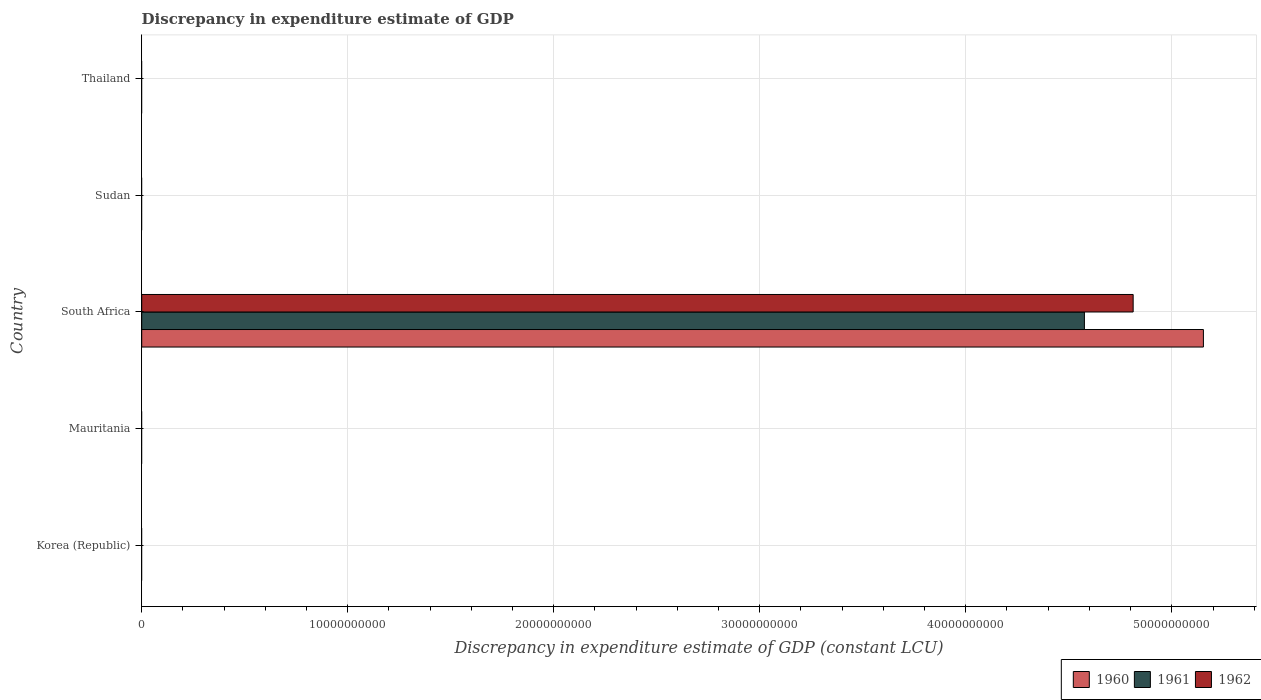Are the number of bars per tick equal to the number of legend labels?
Offer a terse response. No. How many bars are there on the 2nd tick from the top?
Provide a succinct answer. 0. What is the label of the 2nd group of bars from the top?
Keep it short and to the point. Sudan. In how many cases, is the number of bars for a given country not equal to the number of legend labels?
Make the answer very short. 4. Across all countries, what is the maximum discrepancy in expenditure estimate of GDP in 1960?
Ensure brevity in your answer.  5.15e+1. Across all countries, what is the minimum discrepancy in expenditure estimate of GDP in 1961?
Ensure brevity in your answer.  0. In which country was the discrepancy in expenditure estimate of GDP in 1960 maximum?
Make the answer very short. South Africa. What is the total discrepancy in expenditure estimate of GDP in 1960 in the graph?
Provide a short and direct response. 5.15e+1. What is the difference between the discrepancy in expenditure estimate of GDP in 1960 in South Africa and the discrepancy in expenditure estimate of GDP in 1961 in Mauritania?
Keep it short and to the point. 5.15e+1. What is the average discrepancy in expenditure estimate of GDP in 1961 per country?
Make the answer very short. 9.15e+09. What is the difference between the discrepancy in expenditure estimate of GDP in 1961 and discrepancy in expenditure estimate of GDP in 1962 in South Africa?
Provide a succinct answer. -2.37e+09. In how many countries, is the discrepancy in expenditure estimate of GDP in 1962 greater than 26000000000 LCU?
Your response must be concise. 1. What is the difference between the highest and the lowest discrepancy in expenditure estimate of GDP in 1961?
Make the answer very short. 4.58e+1. In how many countries, is the discrepancy in expenditure estimate of GDP in 1961 greater than the average discrepancy in expenditure estimate of GDP in 1961 taken over all countries?
Make the answer very short. 1. Are all the bars in the graph horizontal?
Make the answer very short. Yes. Are the values on the major ticks of X-axis written in scientific E-notation?
Your answer should be compact. No. Does the graph contain any zero values?
Your answer should be very brief. Yes. Does the graph contain grids?
Keep it short and to the point. Yes. How are the legend labels stacked?
Provide a short and direct response. Horizontal. What is the title of the graph?
Provide a short and direct response. Discrepancy in expenditure estimate of GDP. Does "1999" appear as one of the legend labels in the graph?
Ensure brevity in your answer.  No. What is the label or title of the X-axis?
Your answer should be very brief. Discrepancy in expenditure estimate of GDP (constant LCU). What is the label or title of the Y-axis?
Give a very brief answer. Country. What is the Discrepancy in expenditure estimate of GDP (constant LCU) of 1961 in Korea (Republic)?
Offer a very short reply. 0. What is the Discrepancy in expenditure estimate of GDP (constant LCU) in 1962 in Korea (Republic)?
Make the answer very short. 0. What is the Discrepancy in expenditure estimate of GDP (constant LCU) of 1960 in Mauritania?
Keep it short and to the point. 0. What is the Discrepancy in expenditure estimate of GDP (constant LCU) in 1960 in South Africa?
Make the answer very short. 5.15e+1. What is the Discrepancy in expenditure estimate of GDP (constant LCU) in 1961 in South Africa?
Make the answer very short. 4.58e+1. What is the Discrepancy in expenditure estimate of GDP (constant LCU) of 1962 in South Africa?
Make the answer very short. 4.81e+1. What is the Discrepancy in expenditure estimate of GDP (constant LCU) of 1962 in Sudan?
Your answer should be compact. 0. What is the Discrepancy in expenditure estimate of GDP (constant LCU) of 1960 in Thailand?
Keep it short and to the point. 0. What is the Discrepancy in expenditure estimate of GDP (constant LCU) of 1961 in Thailand?
Give a very brief answer. 0. Across all countries, what is the maximum Discrepancy in expenditure estimate of GDP (constant LCU) of 1960?
Make the answer very short. 5.15e+1. Across all countries, what is the maximum Discrepancy in expenditure estimate of GDP (constant LCU) of 1961?
Offer a very short reply. 4.58e+1. Across all countries, what is the maximum Discrepancy in expenditure estimate of GDP (constant LCU) in 1962?
Your answer should be compact. 4.81e+1. Across all countries, what is the minimum Discrepancy in expenditure estimate of GDP (constant LCU) of 1962?
Offer a terse response. 0. What is the total Discrepancy in expenditure estimate of GDP (constant LCU) in 1960 in the graph?
Make the answer very short. 5.15e+1. What is the total Discrepancy in expenditure estimate of GDP (constant LCU) in 1961 in the graph?
Keep it short and to the point. 4.58e+1. What is the total Discrepancy in expenditure estimate of GDP (constant LCU) of 1962 in the graph?
Your answer should be compact. 4.81e+1. What is the average Discrepancy in expenditure estimate of GDP (constant LCU) in 1960 per country?
Your response must be concise. 1.03e+1. What is the average Discrepancy in expenditure estimate of GDP (constant LCU) in 1961 per country?
Provide a succinct answer. 9.15e+09. What is the average Discrepancy in expenditure estimate of GDP (constant LCU) in 1962 per country?
Offer a very short reply. 9.62e+09. What is the difference between the Discrepancy in expenditure estimate of GDP (constant LCU) in 1960 and Discrepancy in expenditure estimate of GDP (constant LCU) in 1961 in South Africa?
Offer a terse response. 5.78e+09. What is the difference between the Discrepancy in expenditure estimate of GDP (constant LCU) of 1960 and Discrepancy in expenditure estimate of GDP (constant LCU) of 1962 in South Africa?
Offer a very short reply. 3.41e+09. What is the difference between the Discrepancy in expenditure estimate of GDP (constant LCU) of 1961 and Discrepancy in expenditure estimate of GDP (constant LCU) of 1962 in South Africa?
Ensure brevity in your answer.  -2.37e+09. What is the difference between the highest and the lowest Discrepancy in expenditure estimate of GDP (constant LCU) in 1960?
Your answer should be compact. 5.15e+1. What is the difference between the highest and the lowest Discrepancy in expenditure estimate of GDP (constant LCU) in 1961?
Your answer should be very brief. 4.58e+1. What is the difference between the highest and the lowest Discrepancy in expenditure estimate of GDP (constant LCU) of 1962?
Your answer should be compact. 4.81e+1. 